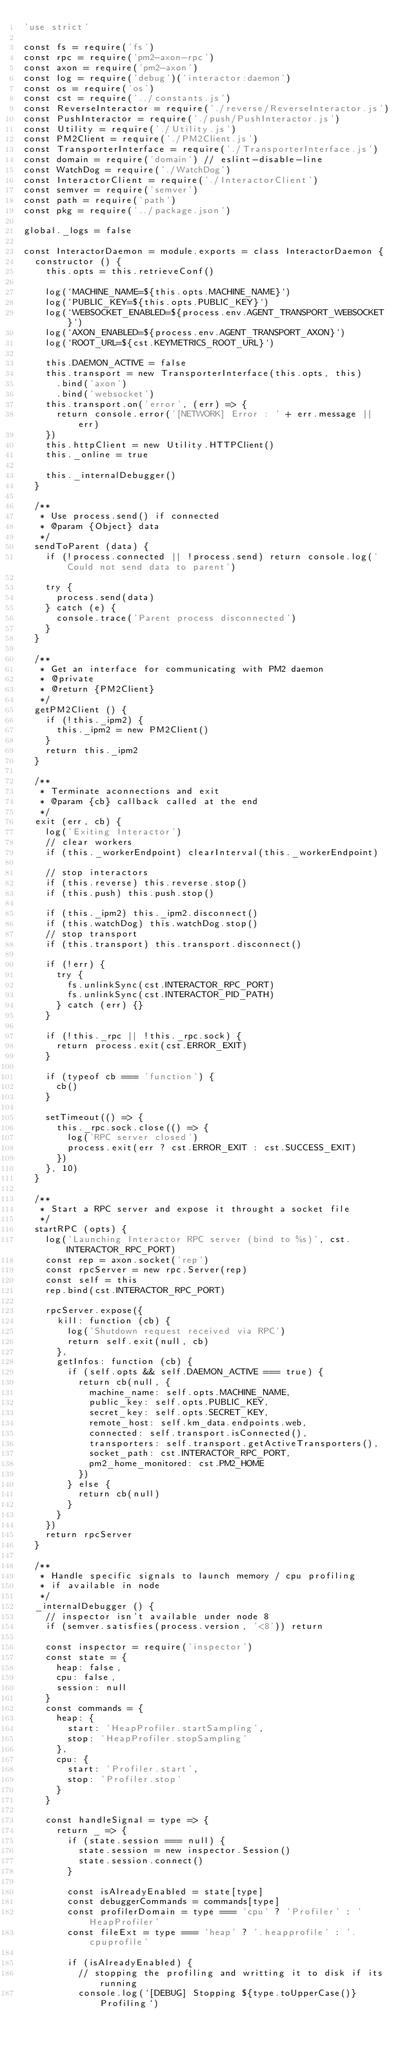Convert code to text. <code><loc_0><loc_0><loc_500><loc_500><_JavaScript_>'use strict'

const fs = require('fs')
const rpc = require('pm2-axon-rpc')
const axon = require('pm2-axon')
const log = require('debug')('interactor:daemon')
const os = require('os')
const cst = require('../constants.js')
const ReverseInteractor = require('./reverse/ReverseInteractor.js')
const PushInteractor = require('./push/PushInteractor.js')
const Utility = require('./Utility.js')
const PM2Client = require('./PM2Client.js')
const TransporterInterface = require('./TransporterInterface.js')
const domain = require('domain') // eslint-disable-line
const WatchDog = require('./WatchDog')
const InteractorClient = require('./InteractorClient')
const semver = require('semver')
const path = require('path')
const pkg = require('../package.json')

global._logs = false

const InteractorDaemon = module.exports = class InteractorDaemon {
  constructor () {
    this.opts = this.retrieveConf()

    log(`MACHINE_NAME=${this.opts.MACHINE_NAME}`)
    log(`PUBLIC_KEY=${this.opts.PUBLIC_KEY}`)
    log(`WEBSOCKET_ENABLED=${process.env.AGENT_TRANSPORT_WEBSOCKET}`)
    log(`AXON_ENABLED=${process.env.AGENT_TRANSPORT_AXON}`)
    log(`ROOT_URL=${cst.KEYMETRICS_ROOT_URL}`)

    this.DAEMON_ACTIVE = false
    this.transport = new TransporterInterface(this.opts, this)
      .bind('axon')
      .bind('websocket')
    this.transport.on('error', (err) => {
      return console.error('[NETWORK] Error : ' + err.message || err)
    })
    this.httpClient = new Utility.HTTPClient()
    this._online = true

    this._internalDebugger()
  }

  /**
   * Use process.send() if connected
   * @param {Object} data
   */
  sendToParent (data) {
    if (!process.connected || !process.send) return console.log('Could not send data to parent')

    try {
      process.send(data)
    } catch (e) {
      console.trace('Parent process disconnected')
    }
  }

  /**
   * Get an interface for communicating with PM2 daemon
   * @private
   * @return {PM2Client}
   */
  getPM2Client () {
    if (!this._ipm2) {
      this._ipm2 = new PM2Client()
    }
    return this._ipm2
  }

  /**
   * Terminate aconnections and exit
   * @param {cb} callback called at the end
   */
  exit (err, cb) {
    log('Exiting Interactor')
    // clear workers
    if (this._workerEndpoint) clearInterval(this._workerEndpoint)

    // stop interactors
    if (this.reverse) this.reverse.stop()
    if (this.push) this.push.stop()

    if (this._ipm2) this._ipm2.disconnect()
    if (this.watchDog) this.watchDog.stop()
    // stop transport
    if (this.transport) this.transport.disconnect()

    if (!err) {
      try {
        fs.unlinkSync(cst.INTERACTOR_RPC_PORT)
        fs.unlinkSync(cst.INTERACTOR_PID_PATH)
      } catch (err) {}
    }

    if (!this._rpc || !this._rpc.sock) {
      return process.exit(cst.ERROR_EXIT)
    }

    if (typeof cb === 'function') {
      cb()
    }

    setTimeout(() => {
      this._rpc.sock.close(() => {
        log('RPC server closed')
        process.exit(err ? cst.ERROR_EXIT : cst.SUCCESS_EXIT)
      })
    }, 10)
  }

  /**
   * Start a RPC server and expose it throught a socket file
   */
  startRPC (opts) {
    log('Launching Interactor RPC server (bind to %s)', cst.INTERACTOR_RPC_PORT)
    const rep = axon.socket('rep')
    const rpcServer = new rpc.Server(rep)
    const self = this
    rep.bind(cst.INTERACTOR_RPC_PORT)

    rpcServer.expose({
      kill: function (cb) {
        log('Shutdown request received via RPC')
        return self.exit(null, cb)
      },
      getInfos: function (cb) {
        if (self.opts && self.DAEMON_ACTIVE === true) {
          return cb(null, {
            machine_name: self.opts.MACHINE_NAME,
            public_key: self.opts.PUBLIC_KEY,
            secret_key: self.opts.SECRET_KEY,
            remote_host: self.km_data.endpoints.web,
            connected: self.transport.isConnected(),
            transporters: self.transport.getActiveTransporters(),
            socket_path: cst.INTERACTOR_RPC_PORT,
            pm2_home_monitored: cst.PM2_HOME
          })
        } else {
          return cb(null)
        }
      }
    })
    return rpcServer
  }

  /**
   * Handle specific signals to launch memory / cpu profiling
   * if available in node
   */
  _internalDebugger () {
    // inspector isn't available under node 8
    if (semver.satisfies(process.version, '<8')) return

    const inspector = require('inspector')
    const state = {
      heap: false,
      cpu: false,
      session: null
    }
    const commands = {
      heap: {
        start: 'HeapProfiler.startSampling',
        stop: 'HeapProfiler.stopSampling'
      },
      cpu: {
        start: 'Profiler.start',
        stop: 'Profiler.stop'
      }
    }

    const handleSignal = type => {
      return _ => {
        if (state.session === null) {
          state.session = new inspector.Session()
          state.session.connect()
        }

        const isAlreadyEnabled = state[type]
        const debuggerCommands = commands[type]
        const profilerDomain = type === 'cpu' ? 'Profiler' : 'HeapProfiler'
        const fileExt = type === 'heap' ? '.heapprofile' : '.cpuprofile'

        if (isAlreadyEnabled) {
          // stopping the profiling and writting it to disk if its running
          console.log(`[DEBUG] Stopping ${type.toUpperCase()} Profiling`)</code> 